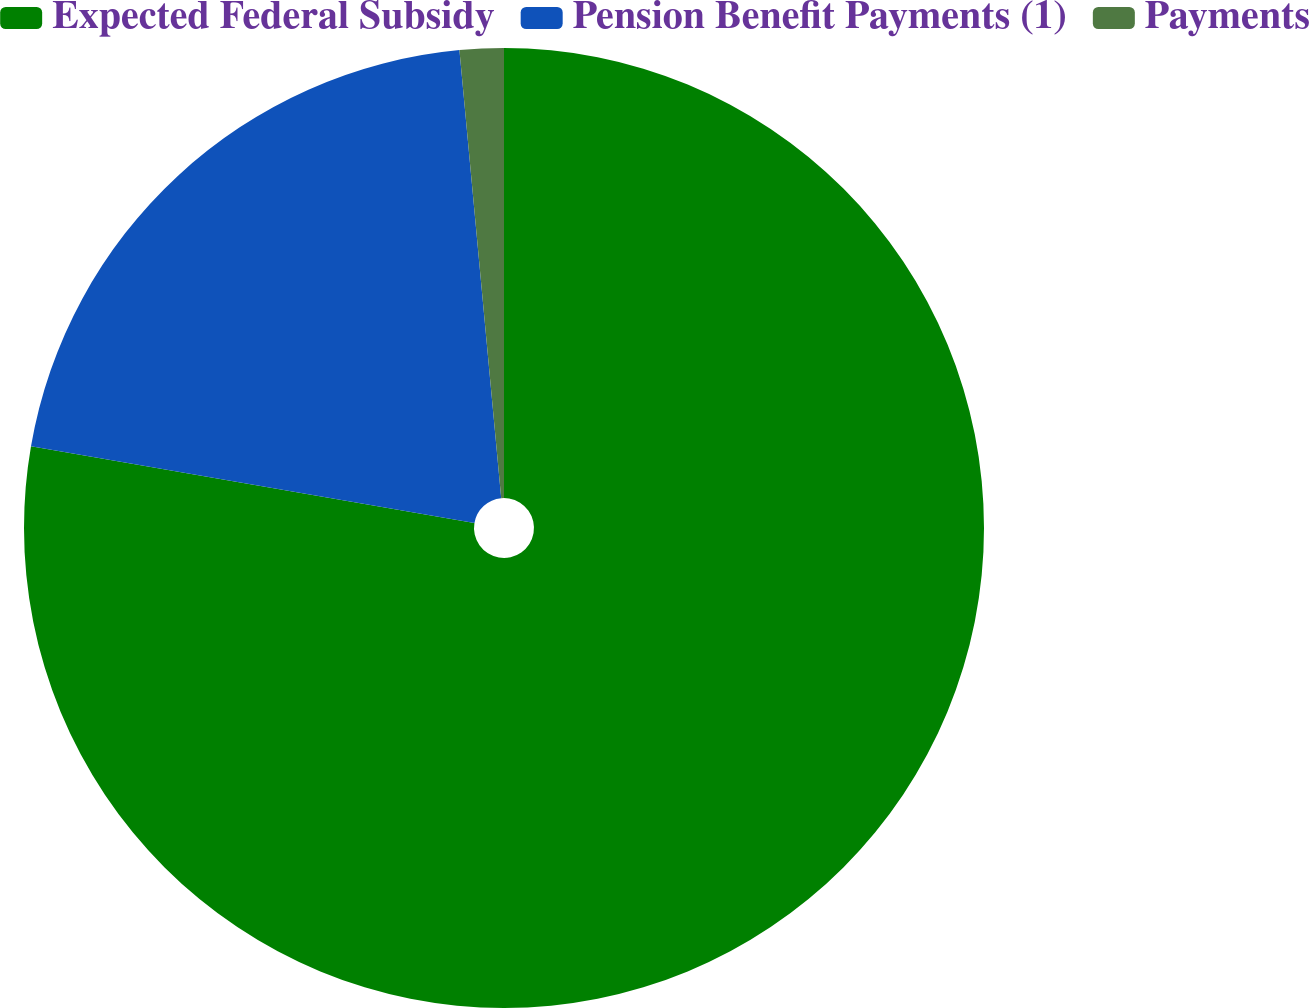Convert chart. <chart><loc_0><loc_0><loc_500><loc_500><pie_chart><fcel>Expected Federal Subsidy<fcel>Pension Benefit Payments (1)<fcel>Payments<nl><fcel>77.72%<fcel>20.8%<fcel>1.48%<nl></chart> 